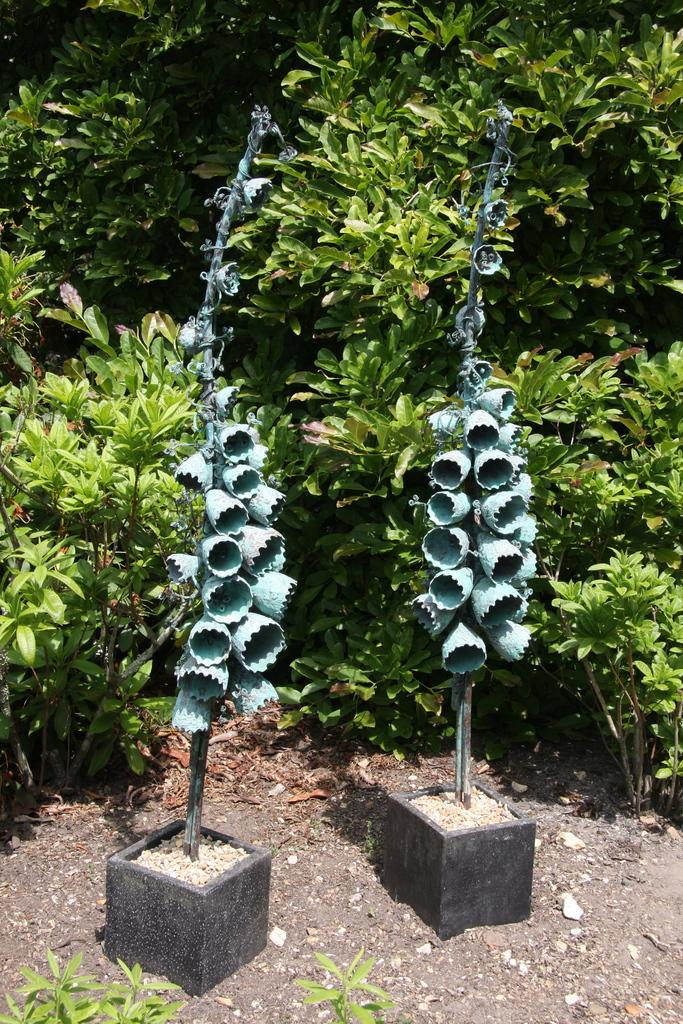What type of objects can be seen in the image? There are metal rods and lamps in the image. What else is present in the image besides the metal rods and lamps? There are trees in the image. Can you determine the time of day when the image was taken? The image was likely taken during the day, as there is sufficient light to see the objects clearly. How much sugar is in the alley in the image? There is no alley or sugar present in the image. What type of calculator can be seen on the trees in the image? There are no calculators present on the trees in the image. 